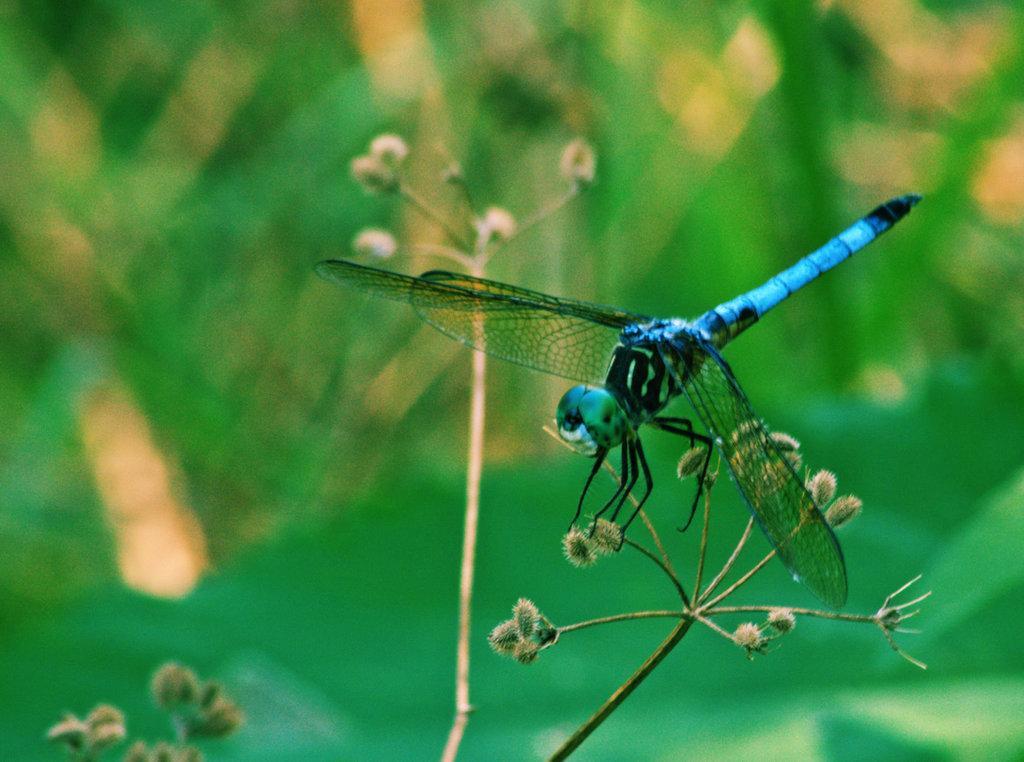Describe this image in one or two sentences. In this picture we can see dragonfly, flowers and stems. In the background of the image it is blue and green. 